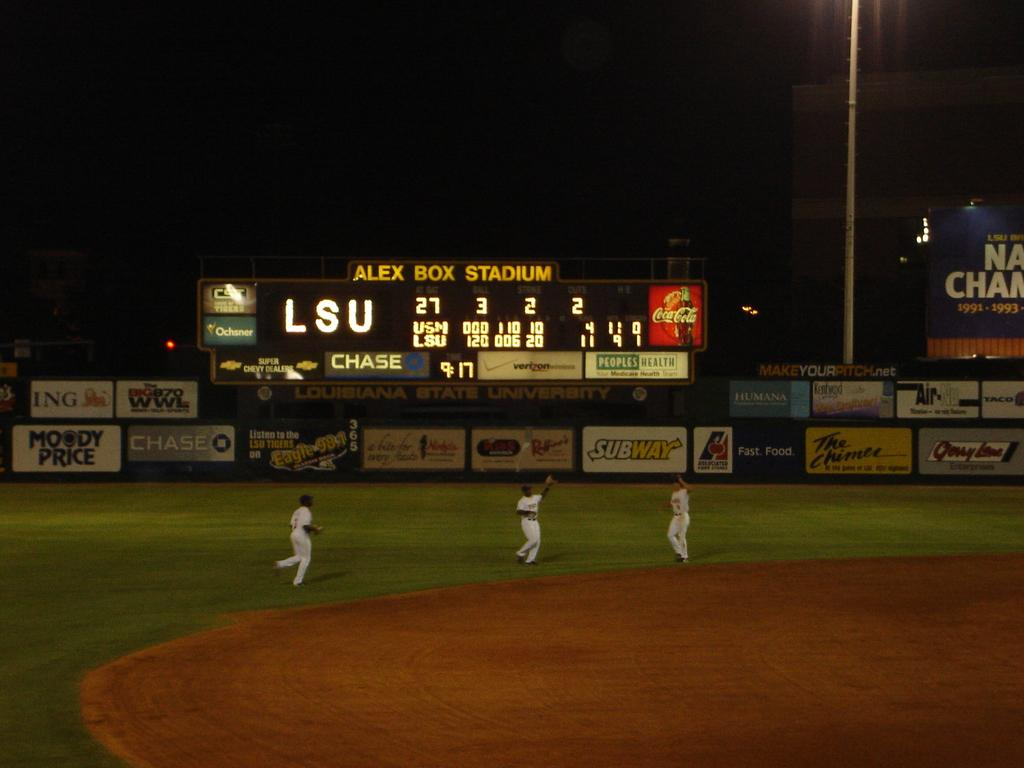<image>
Present a compact description of the photo's key features. A baseball stadium is labeled ALEX BOX STADIUM on the scoreboard. 